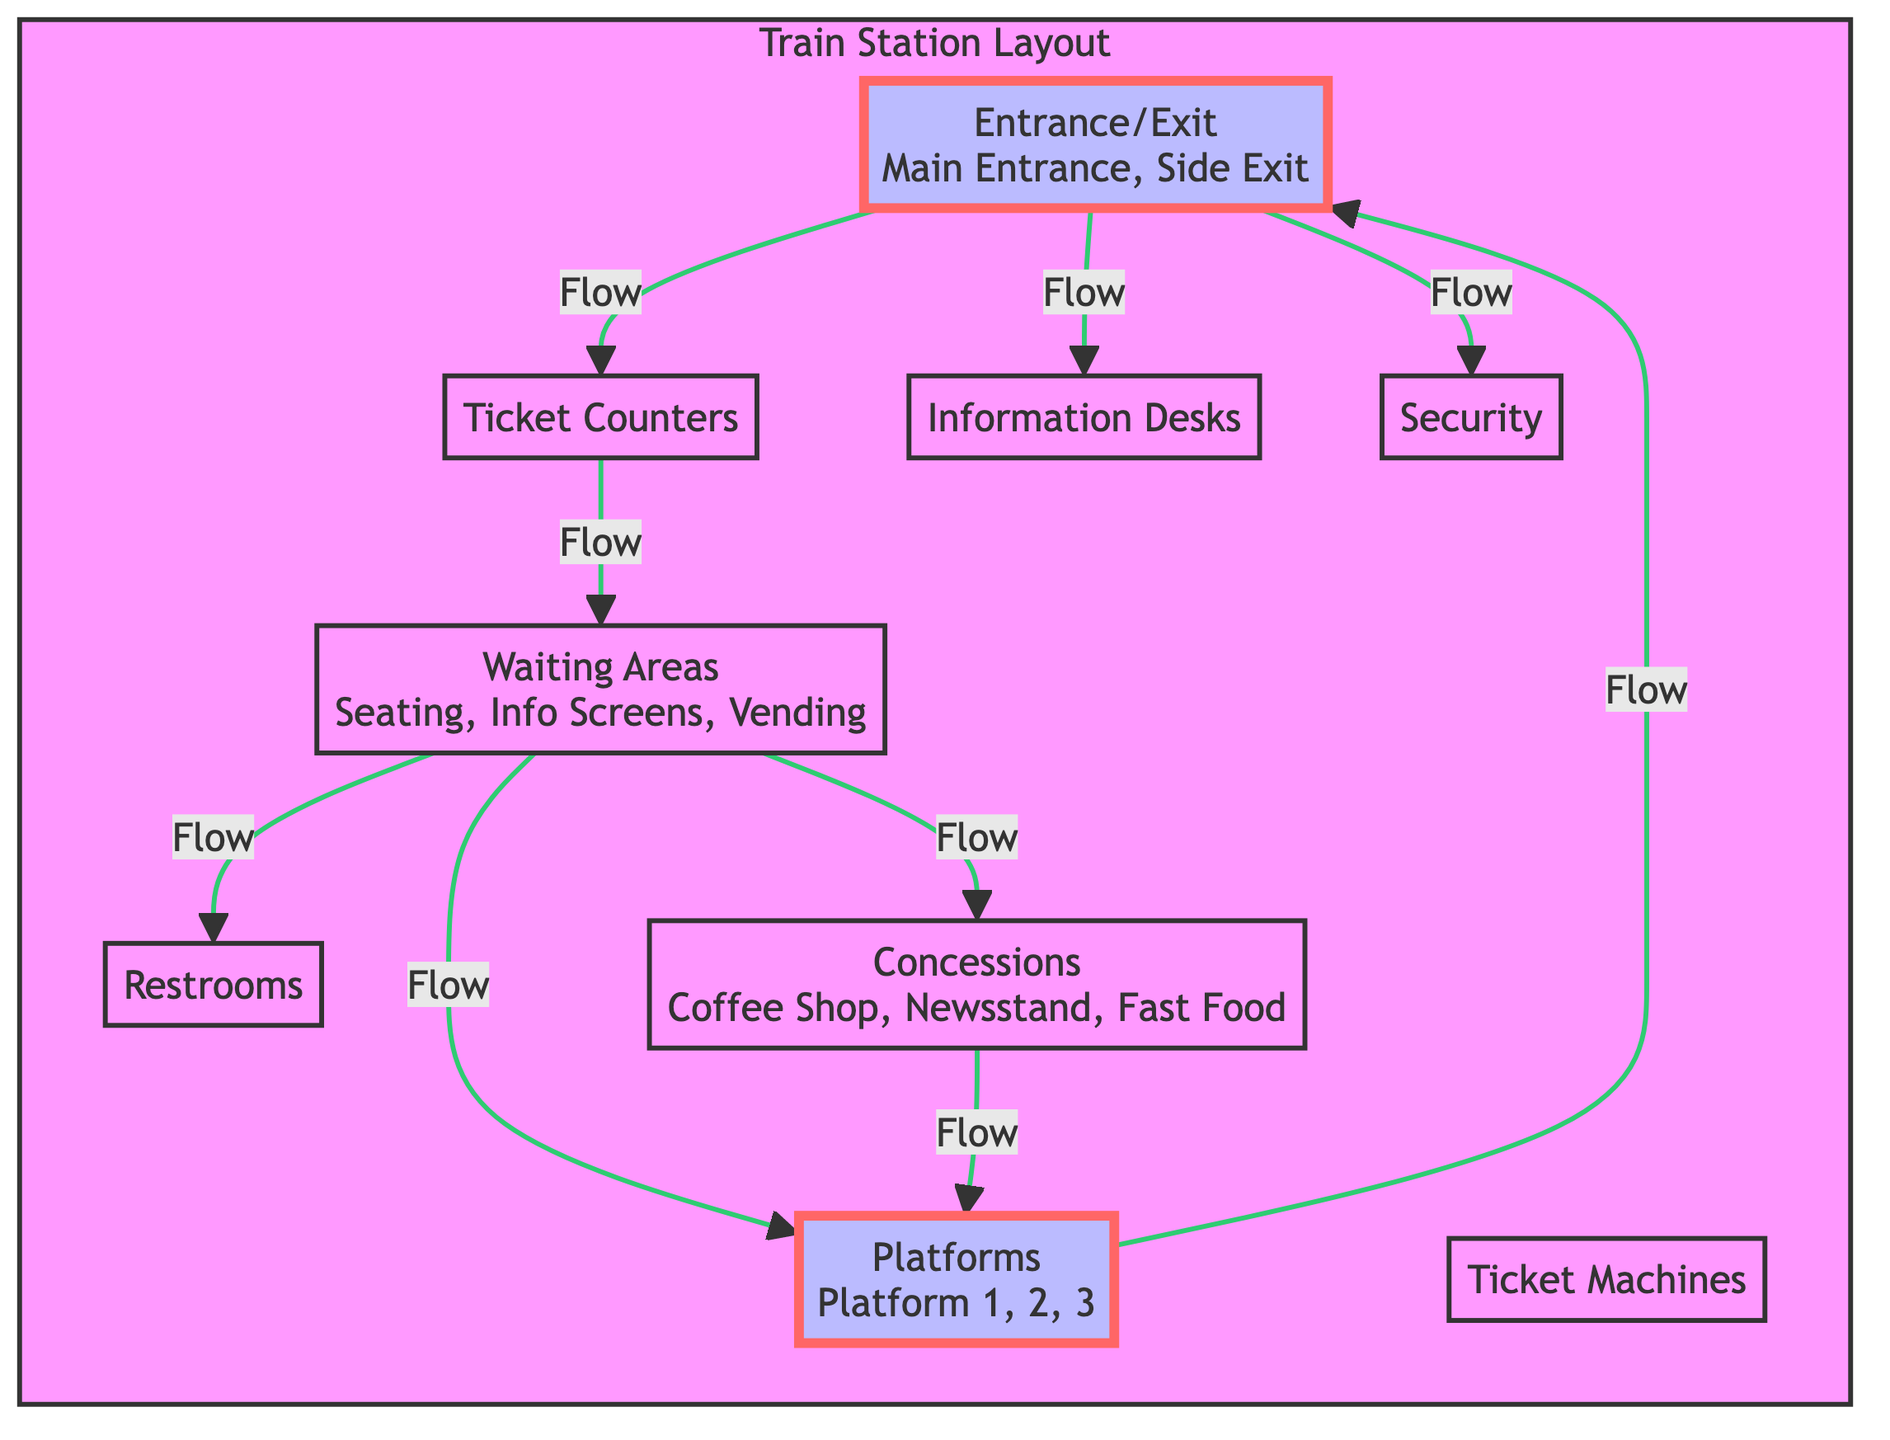What is the main entrance location in the diagram? The main entrance is represented as "Entrance/Exit" in the diagram, indicating where passengers enter and exit the station.
Answer: Entrance/Exit How many platforms are there in the train station according to the diagram? The diagram specifies three platforms labeled as "Platform 1, 2, 3," indicating there are three in total.
Answer: 3 What are the facilities available in the waiting areas? The waiting areas include "Seating, Info Screens, Vending" as listed in the node description, representing the various amenities provided in those areas.
Answer: Seating, Info Screens, Vending What is the flow connection from the ticket counters to waiting areas? The diagram shows a direct edge connecting "Ticket Counters" to "Waiting Areas," indicating that passengers move from the ticket counters to the waiting areas.
Answer: Flow Which critical facility connects the platforms and concessions? The diagram illustrates a flow from "Concessions" to "Platforms," showing that passengers can reach the platforms from the concession area directly.
Answer: Platforms What is the purpose of the information desks in the station layout? The "Information Desks" are linked to the "Entrance/Exit," suggesting they provide information to passengers as they enter or exit the station.
Answer: Information How does the flow of passengers move from the entrance to the platforms? Starting at the "Entrance/Exit," passengers can either go to "Ticket Counters" or "Information Desks," which then guides them to "Waiting Areas," and from there to the "Platforms," showing a clear flow to reach the train.
Answer: Entrance to Platforms What role does security play in the overall passenger flow? The "Security" area is connected to the "Entrance/Exit," suggesting that all passengers must pass through security before reaching the other facilities like ticket counters or waiting areas.
Answer: Security What additional facility connects to ticket machines in the station? The diagram indicates that "Ticket Machines" are included within the layout but do not show direct flows to them from other facilities, implying they are readily available.
Answer: Ticket Machines 